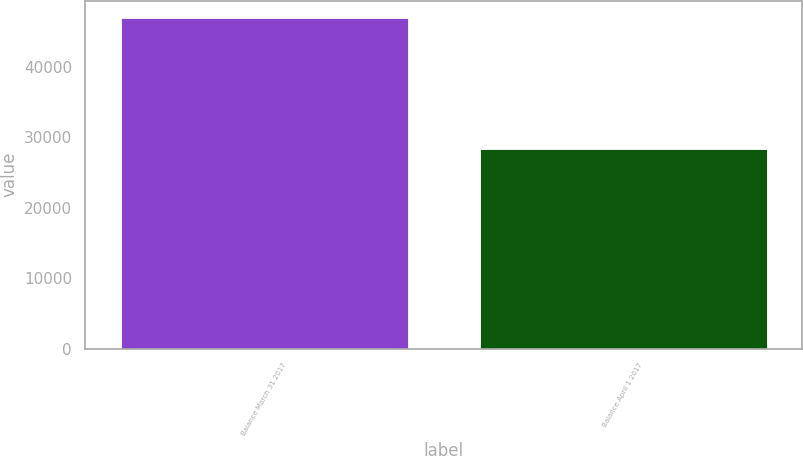Convert chart. <chart><loc_0><loc_0><loc_500><loc_500><bar_chart><fcel>Balance March 31 2017<fcel>Balance April 1 2017<nl><fcel>46959<fcel>28287<nl></chart> 